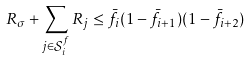<formula> <loc_0><loc_0><loc_500><loc_500>R _ { \sigma } + \sum _ { j \in \mathcal { S } _ { i } ^ { f } } R _ { j } \leq \bar { f } _ { i } ( 1 - \bar { f } _ { i + 1 } ) ( 1 - \bar { f } _ { i + 2 } )</formula> 